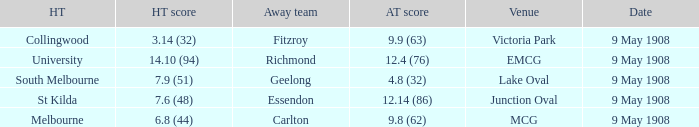Name the home team score for south melbourne home team 7.9 (51). 